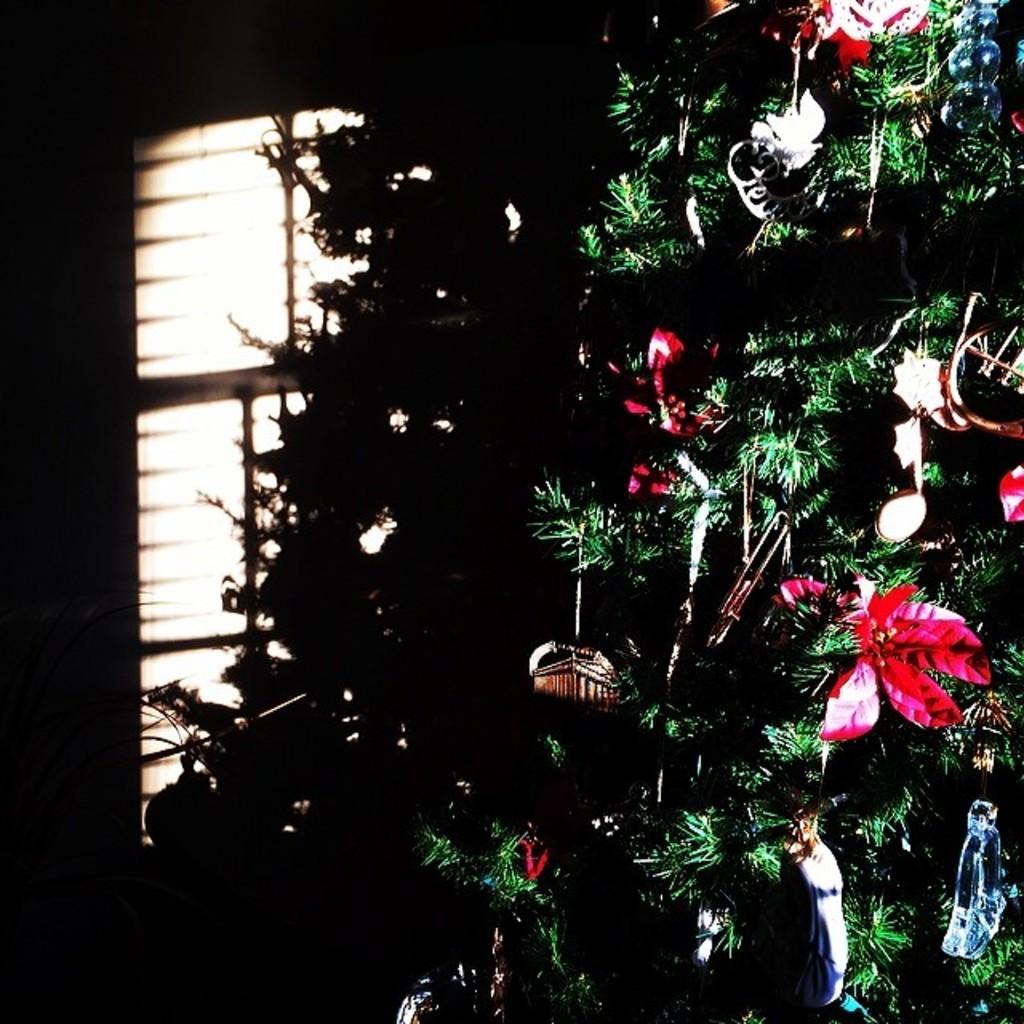Could you give a brief overview of what you see in this image? In this image there is a Christmas tree having decorative items hanging to it. Background there is a wall having a window. 